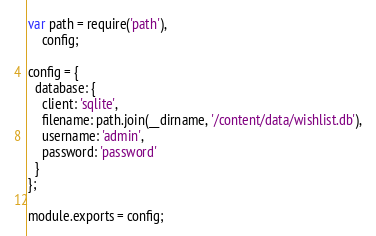Convert code to text. <code><loc_0><loc_0><loc_500><loc_500><_JavaScript_>var path = require('path'),
    config;

config = {
  database: {
    client: 'sqlite',
    filename: path.join(__dirname, '/content/data/wishlist.db'),
    username: 'admin',
    password: 'password'
  }
};

module.exports = config;
</code> 